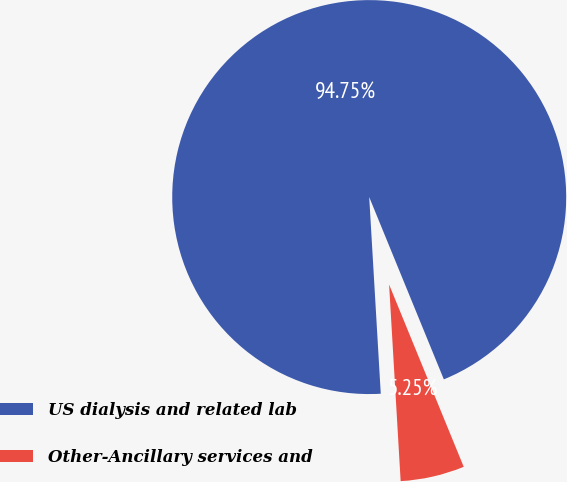Convert chart to OTSL. <chart><loc_0><loc_0><loc_500><loc_500><pie_chart><fcel>US dialysis and related lab<fcel>Other-Ancillary services and<nl><fcel>94.75%<fcel>5.25%<nl></chart> 